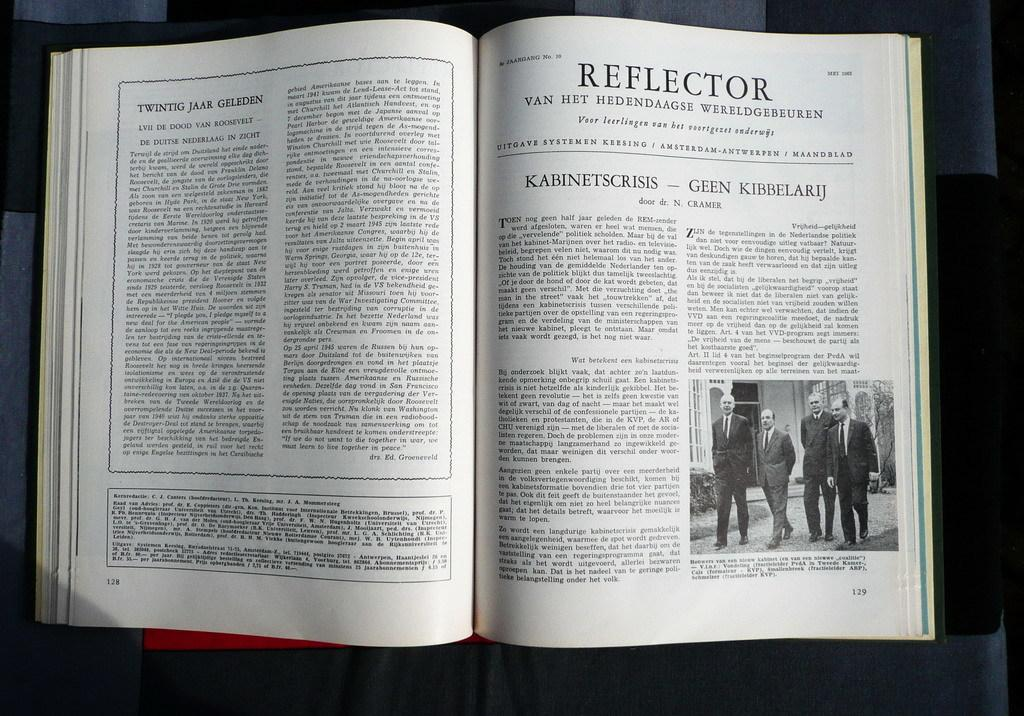<image>
Give a short and clear explanation of the subsequent image. A book is open to page 128 with an article titled "Twintig Jaar Geleden" and page 129 which is titled "Reflector" 